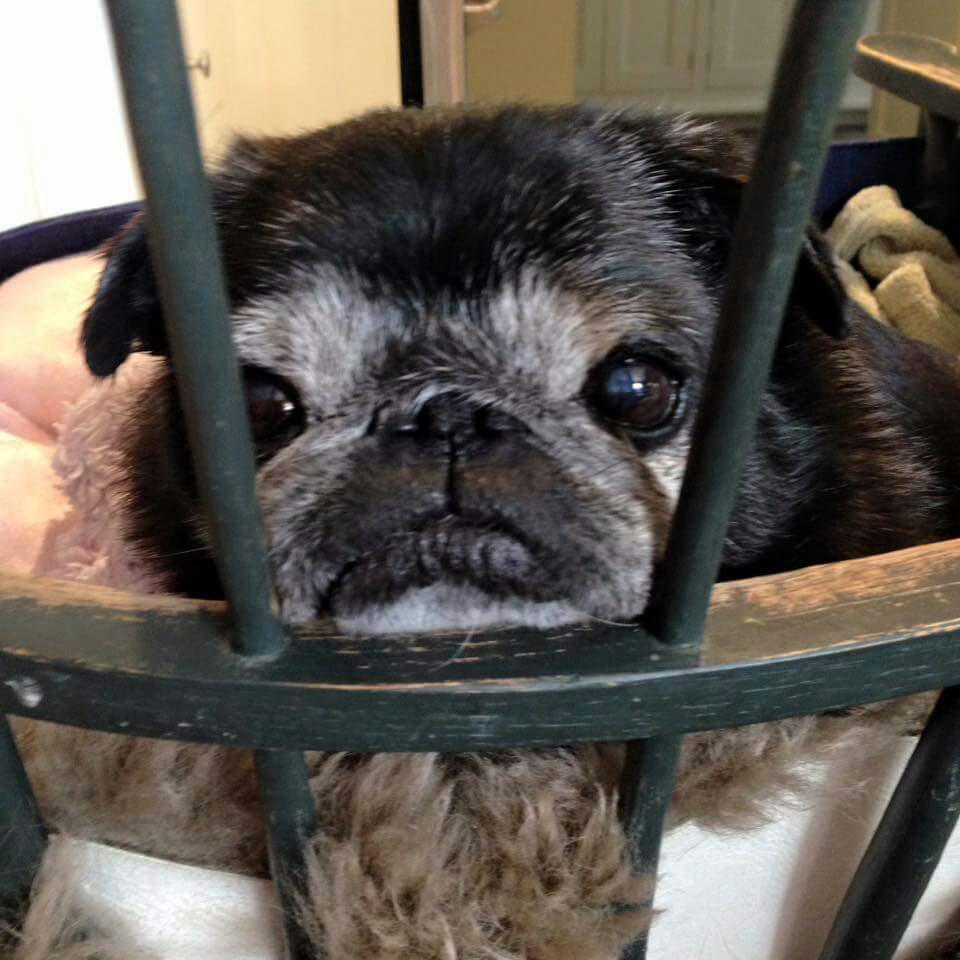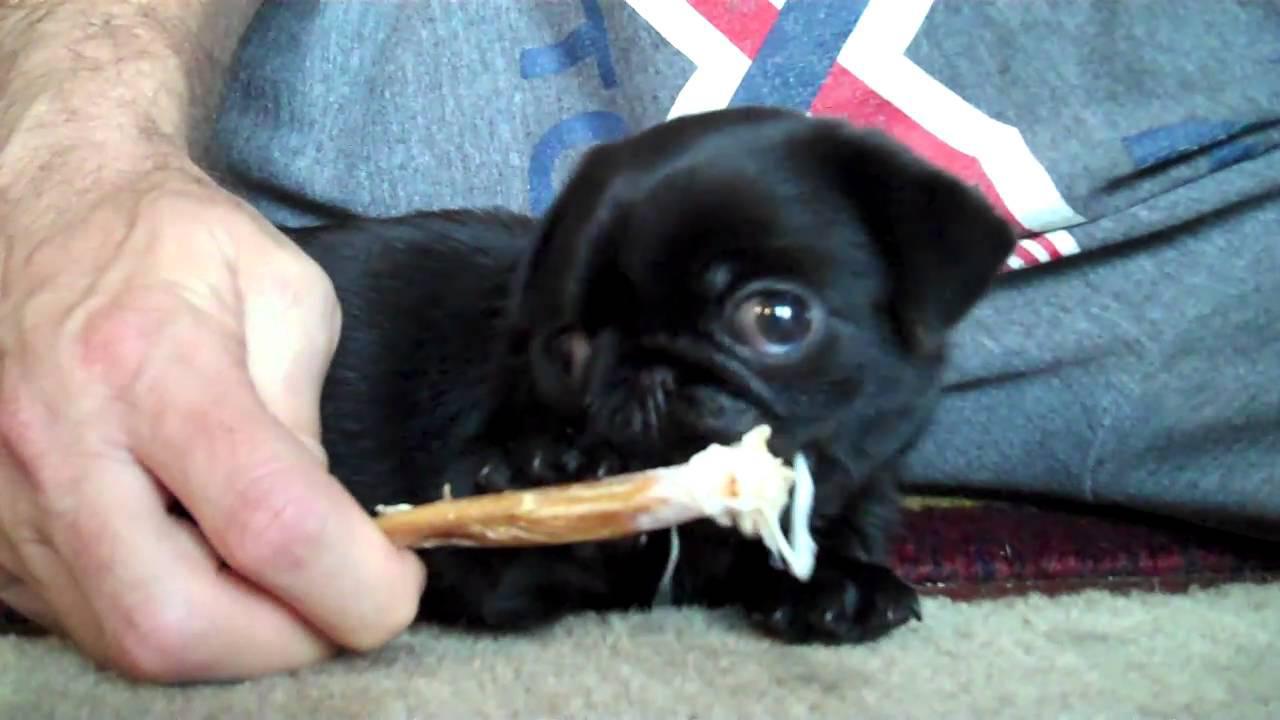The first image is the image on the left, the second image is the image on the right. Examine the images to the left and right. Is the description "The right image contains one black pug and a human hand, and no image contains a standing dog." accurate? Answer yes or no. Yes. The first image is the image on the left, the second image is the image on the right. Assess this claim about the two images: "There is only one dog in each of the images.". Correct or not? Answer yes or no. Yes. 